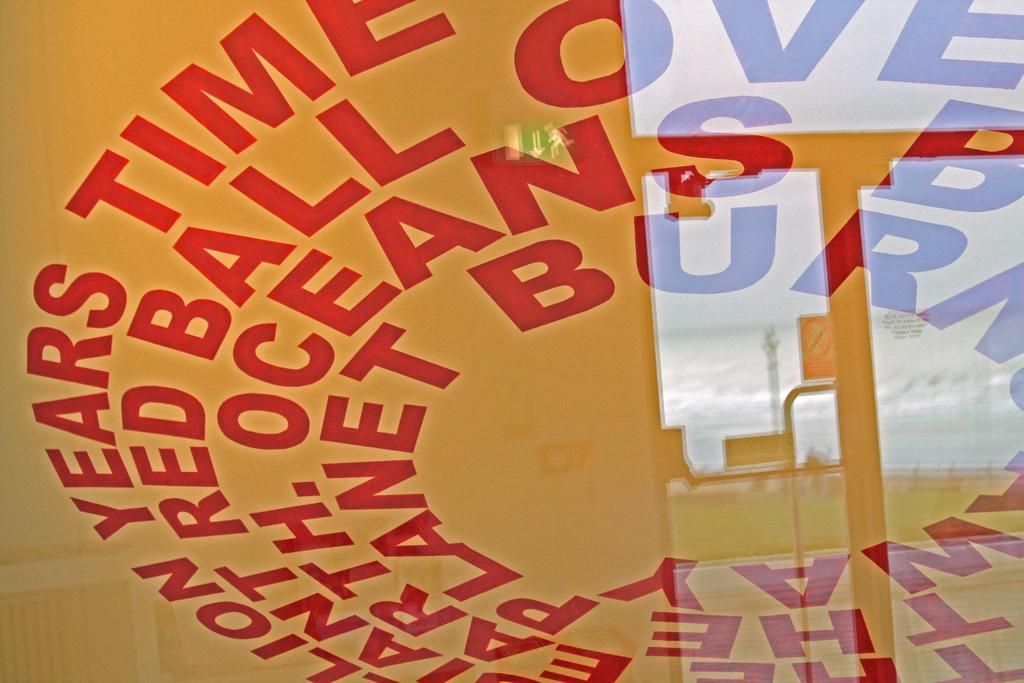<image>
Provide a brief description of the given image. The word Time is visible in red on white here. 